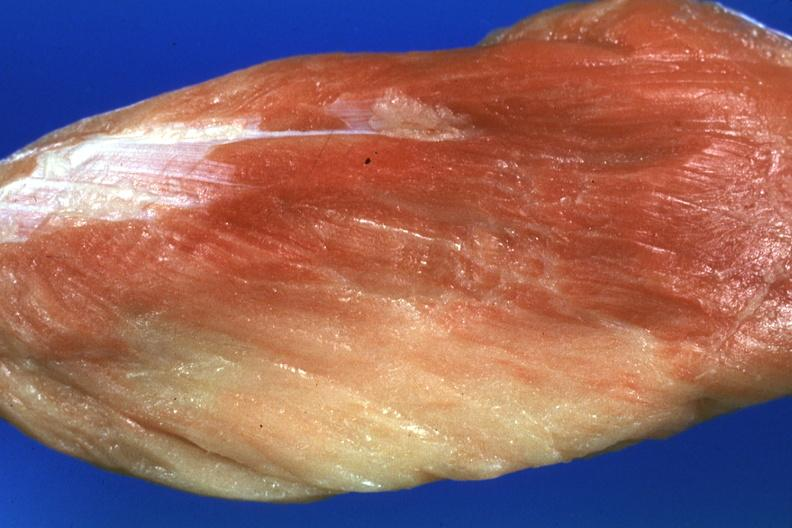what does this image show?
Answer the question using a single word or phrase. Close-up with some red muscle remaining 